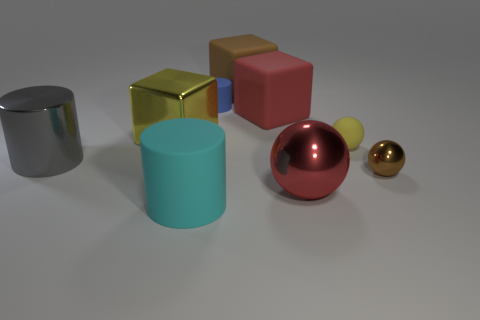What material is the big thing that is both in front of the large metal cube and right of the cyan object?
Your answer should be compact. Metal. What is the color of the tiny shiny thing that is the same shape as the big red shiny object?
Your answer should be very brief. Brown. There is a cube behind the tiny blue matte cylinder; are there any large metal blocks right of it?
Keep it short and to the point. No. The rubber sphere has what size?
Offer a very short reply. Small. What is the shape of the metallic thing that is both to the left of the large ball and in front of the yellow matte ball?
Offer a very short reply. Cylinder. How many red things are small objects or small rubber blocks?
Keep it short and to the point. 0. There is a brown thing in front of the metallic block; does it have the same size as the yellow object on the left side of the big metallic sphere?
Offer a very short reply. No. How many things are large cyan objects or tiny gray cylinders?
Offer a very short reply. 1. Are there any big gray rubber objects that have the same shape as the large cyan matte object?
Provide a succinct answer. No. Are there fewer gray shiny balls than yellow metallic cubes?
Make the answer very short. Yes. 